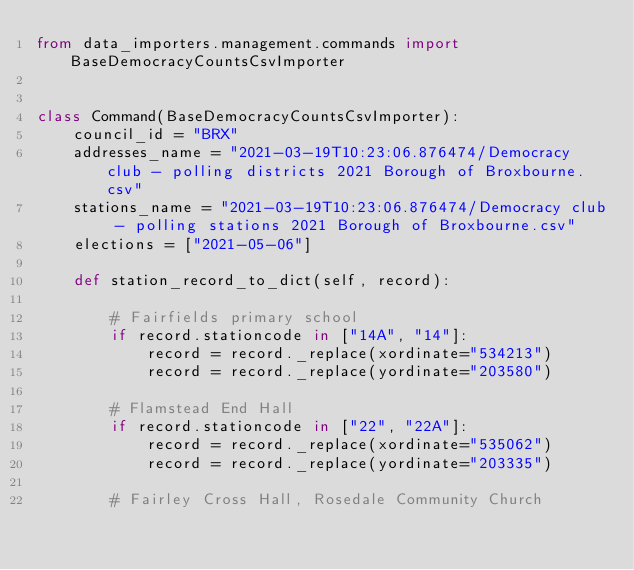Convert code to text. <code><loc_0><loc_0><loc_500><loc_500><_Python_>from data_importers.management.commands import BaseDemocracyCountsCsvImporter


class Command(BaseDemocracyCountsCsvImporter):
    council_id = "BRX"
    addresses_name = "2021-03-19T10:23:06.876474/Democracy club - polling districts 2021 Borough of Broxbourne.csv"
    stations_name = "2021-03-19T10:23:06.876474/Democracy club - polling stations 2021 Borough of Broxbourne.csv"
    elections = ["2021-05-06"]

    def station_record_to_dict(self, record):

        # Fairfields primary school
        if record.stationcode in ["14A", "14"]:
            record = record._replace(xordinate="534213")
            record = record._replace(yordinate="203580")

        # Flamstead End Hall
        if record.stationcode in ["22", "22A"]:
            record = record._replace(xordinate="535062")
            record = record._replace(yordinate="203335")

        # Fairley Cross Hall, Rosedale Community Church</code> 